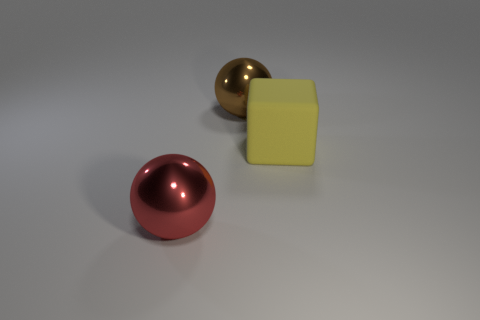Add 2 small gray shiny objects. How many objects exist? 5 Subtract all cubes. How many objects are left? 2 Subtract 1 yellow cubes. How many objects are left? 2 Subtract all cubes. Subtract all brown things. How many objects are left? 1 Add 1 blocks. How many blocks are left? 2 Add 3 big red metal balls. How many big red metal balls exist? 4 